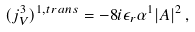<formula> <loc_0><loc_0><loc_500><loc_500>( j ^ { 3 } _ { V } ) ^ { 1 , t r a n s } = - 8 i \epsilon _ { r } \alpha ^ { 1 } | A | ^ { 2 } \, ,</formula> 